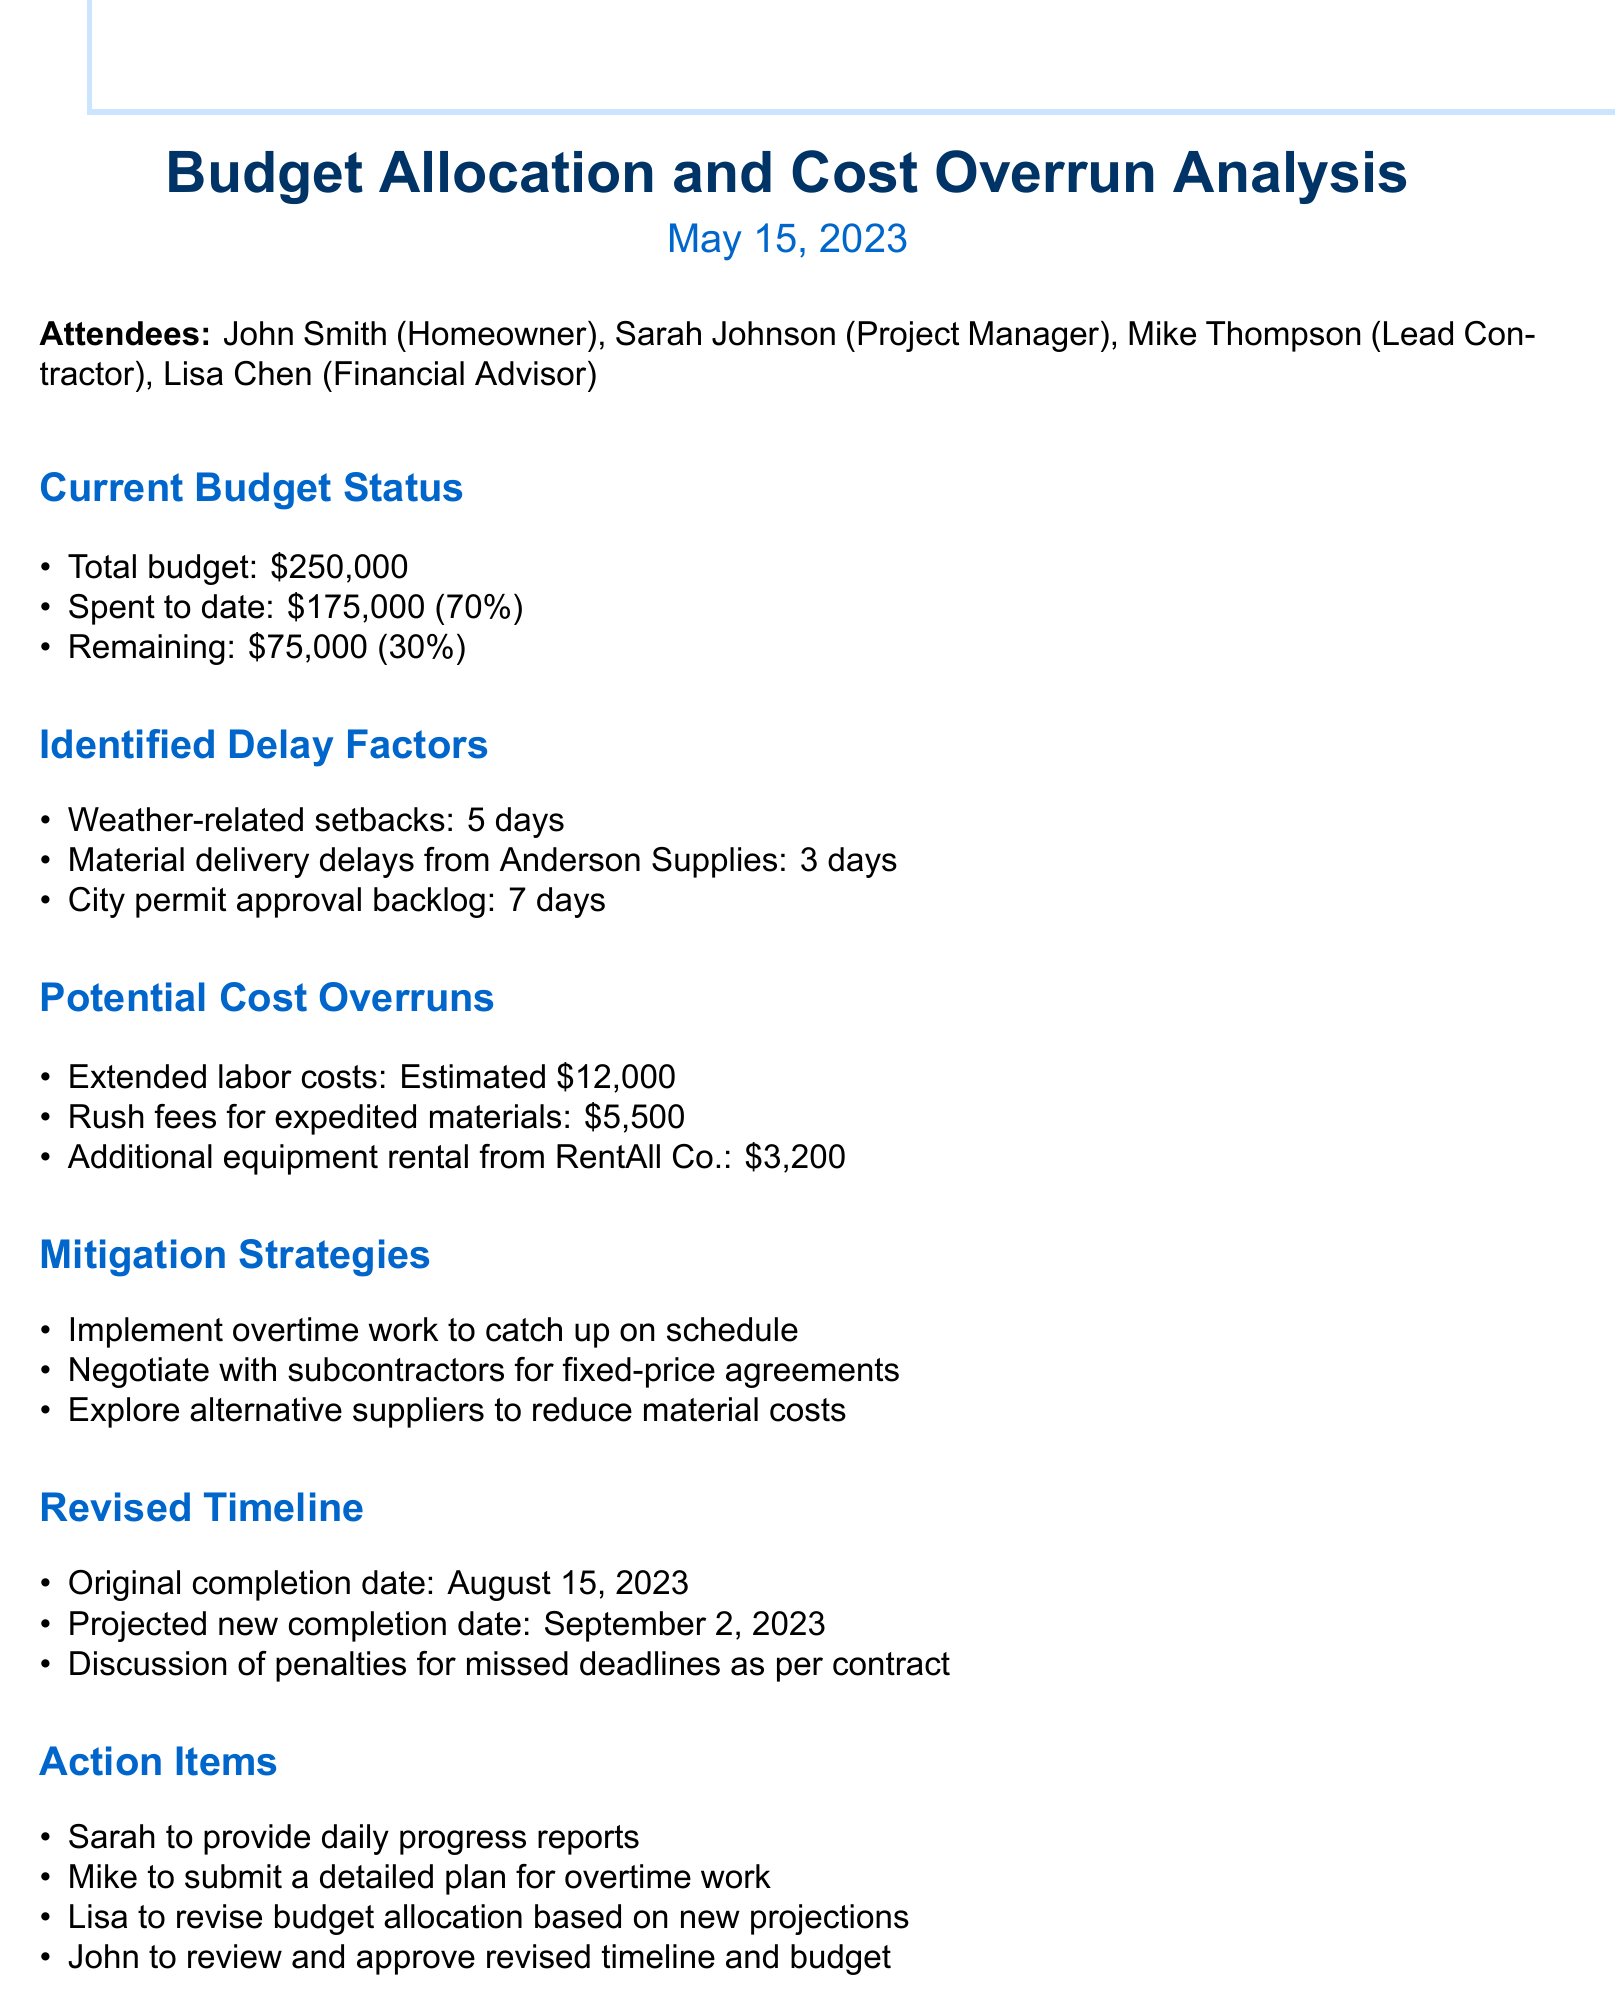what is the total budget? The total budget is clearly stated in the document as $250,000.
Answer: $250,000 how much of the budget has been spent to date? The document notes that $175,000 has been spent to date, which is 70% of the total budget.
Answer: $175,000 what are the top three identified delay factors? The document lists weather-related setbacks, material delivery delays, and city permit approval backlog as the top three delay factors.
Answer: Weather-related setbacks, Material delivery delays, City permit approval backlog what is the estimated cost of extended labor? According to the document, the estimated cost of extended labor is $12,000.
Answer: $12,000 what is the projected new completion date? The projected new completion date provided in the document is September 2, 2023.
Answer: September 2, 2023 who is responsible for providing daily progress reports? The document states that Sarah is responsible for providing daily progress reports.
Answer: Sarah what percentage of the budget is remaining? The document states that 30% of the budget is remaining.
Answer: 30% what is one of the mitigation strategies proposed? The document mentions implementing overtime work to catch up on schedule as one of the mitigation strategies.
Answer: Implement overtime work what penalties are being discussed for missed deadlines? The document indicates that there is a discussion of penalties for missed deadlines as per the contract.
Answer: Penalties for missed deadlines as per contract 